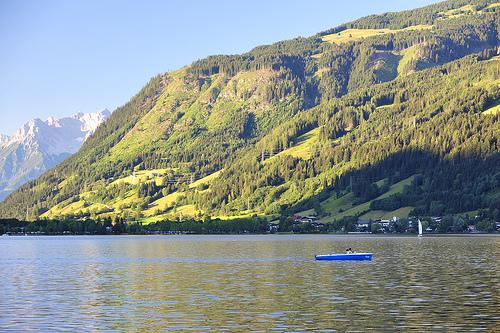Question: how many boat are there?
Choices:
A. Two.
B. One.
C. Three.
D. Four.
Answer with the letter. Answer: B Question: what is in the background?
Choices:
A. Field.
B. Trees.
C. Canyon.
D. Beach.
Answer with the letter. Answer: B Question: what is the color of the trees?
Choices:
A. Orange.
B. Green.
C. Brown.
D. Red.
Answer with the letter. Answer: B 